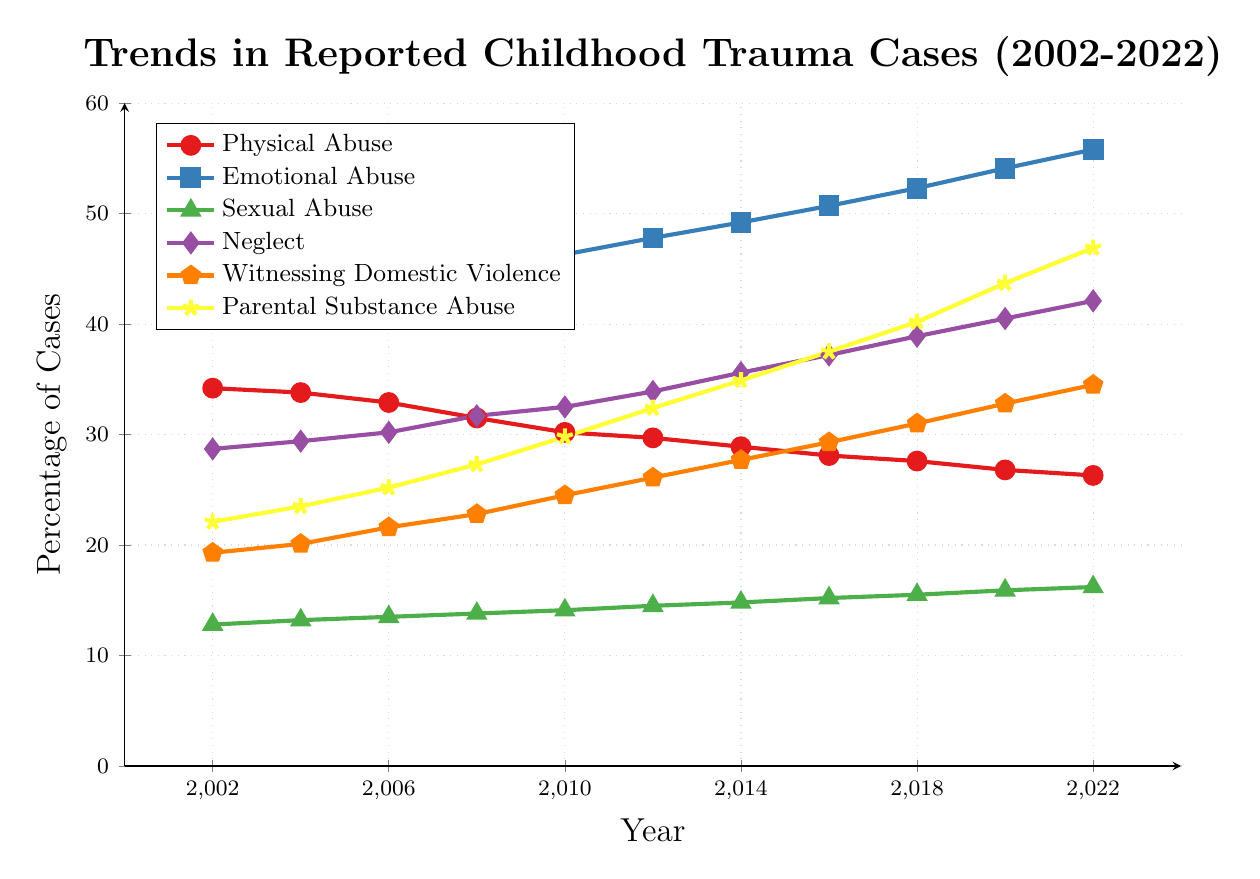What trend is observed in the cases of Emotional Abuse from 2002 to 2022? To find the trend, we track the line representing Emotional Abuse from 2002 to 2022. The data points increase each year: starting from 41.5% in 2002 and ending at 55.8% in 2022. This indicates a rising trend over the years.
Answer: Increasing Which type of trauma had the highest reported cases in 2022? At 2022, we compare the heights of all lines representing different traumas. Emotional Abuse reaches the highest value at 55.8%.
Answer: Emotional Abuse What is the difference in the percentage of cases between Physical Abuse and Neglect in 2010? In 2010, the data points for Physical Abuse and Neglect are 30.2% and 32.5%, respectively. The difference is calculated as 32.5% - 30.2% = 2.3%.
Answer: 2.3% How has the percentage of cases for Parental Substance Abuse changed from 2004 to 2022? We identify the values for Parental Substance Abuse in 2004 and 2022, which are 23.5% and 46.9%, respectively. The change is calculated as 46.9% - 23.5% = 23.4%.
Answer: 23.4% Which type of trauma consistently shows a decrease in reported cases from 2002 to 2022? By examining each line, only the Physical Abuse line shows a consistent decrease from 34.2% in 2002 to 26.3% in 2022.
Answer: Physical Abuse Between 2008 and 2018, which type of trauma showed the greatest increase in reported cases? We compare the increases for each type of trauma between 2008 and 2018: Physical Abuse (31.5% to 27.6%, decrease), Emotional Abuse (44.9% to 52.3%, increase of 7.4%), Sexual Abuse (13.8% to 15.5%, increase of 1.7%), Neglect (31.7% to 38.9%, increase of 7.2%), Witnessing Domestic Violence (22.8% to 31%, increase of 8.2%), Parental Substance Abuse (27.3% to 40.2%, increase of 12.9%). Parental Substance Abuse has the greatest increase.
Answer: Parental Substance Abuse Is there any type of trauma where the percentage of cases exceeds 50%? If yes, which one? We observe the y-axis and see which lines cross the 50% mark. Only the Emotional Abuse line exceeds 50%, reaching 55.8% by 2022.
Answer: Emotional Abuse What is the average percentage of Sexual Abuse cases recorded over the two decades? To find the average, sum the percentages for Sexual Abuse from each year and divide by the number of years (11). The values are: 12.8, 13.2, 13.5, 13.8, 14.1, 14.5, 14.8, 15.2, 15.5, 15.9, 16.2. The sum is 159.5, and the average is 159.5 / 11 ≈ 14.5%.
Answer: 14.5% If you sum the percentages for Emotional Abuse and Neglect in 2012, what is the total? Adding the percentages for Emotional Abuse (47.8%) and Neglect (33.9%) in 2012: 47.8 + 33.9 = 81.7%.
Answer: 81.7% How many years show the percentage of Witnessing Domestic Violence above 30%? Observing the line for Witnessing Domestic Violence, the percentages surpass 30% in three years: 2018 (31.0%), 2020 (32.8%), and 2022 (34.5%).
Answer: 3 